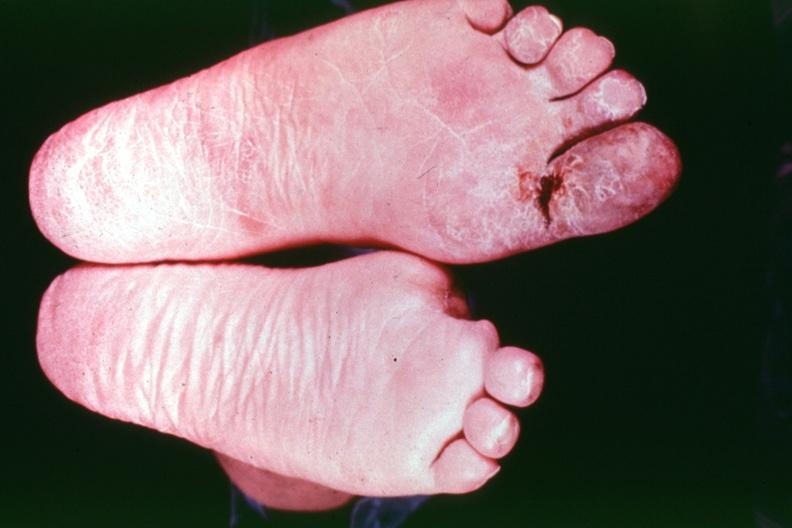re extremities present?
Answer the question using a single word or phrase. Yes 